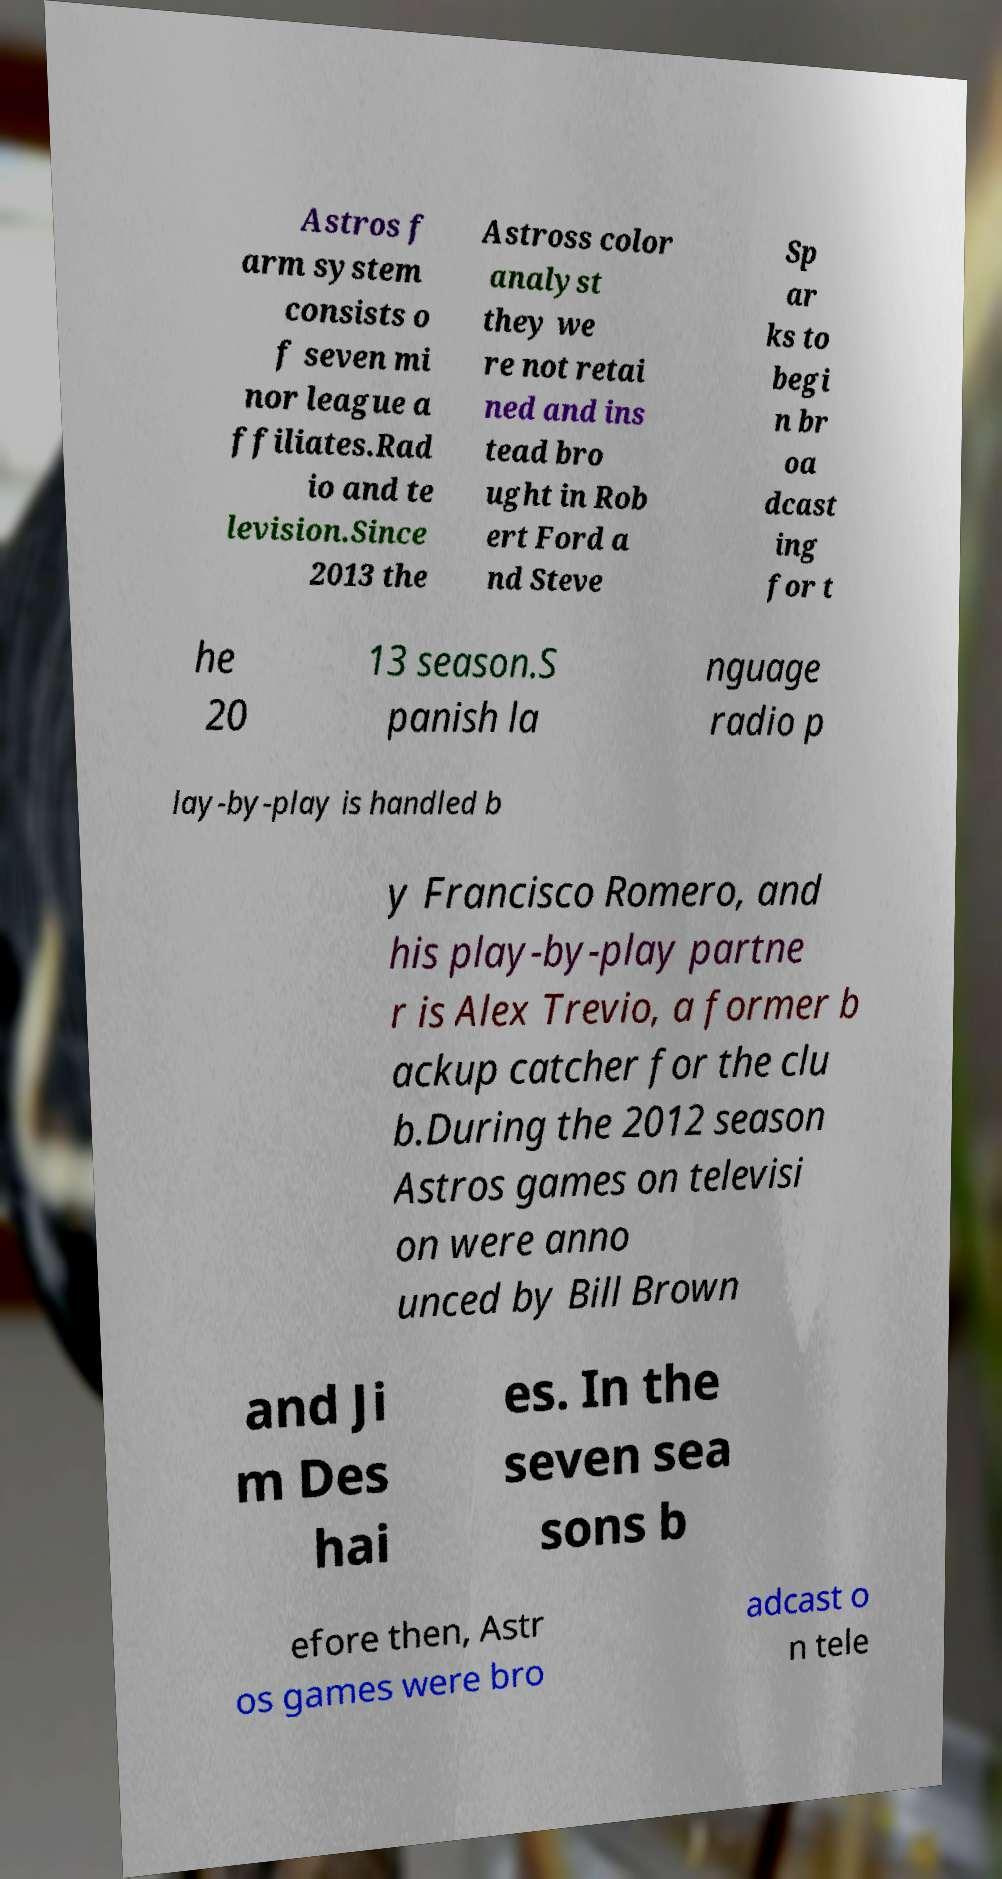There's text embedded in this image that I need extracted. Can you transcribe it verbatim? Astros f arm system consists o f seven mi nor league a ffiliates.Rad io and te levision.Since 2013 the Astross color analyst they we re not retai ned and ins tead bro ught in Rob ert Ford a nd Steve Sp ar ks to begi n br oa dcast ing for t he 20 13 season.S panish la nguage radio p lay-by-play is handled b y Francisco Romero, and his play-by-play partne r is Alex Trevio, a former b ackup catcher for the clu b.During the 2012 season Astros games on televisi on were anno unced by Bill Brown and Ji m Des hai es. In the seven sea sons b efore then, Astr os games were bro adcast o n tele 